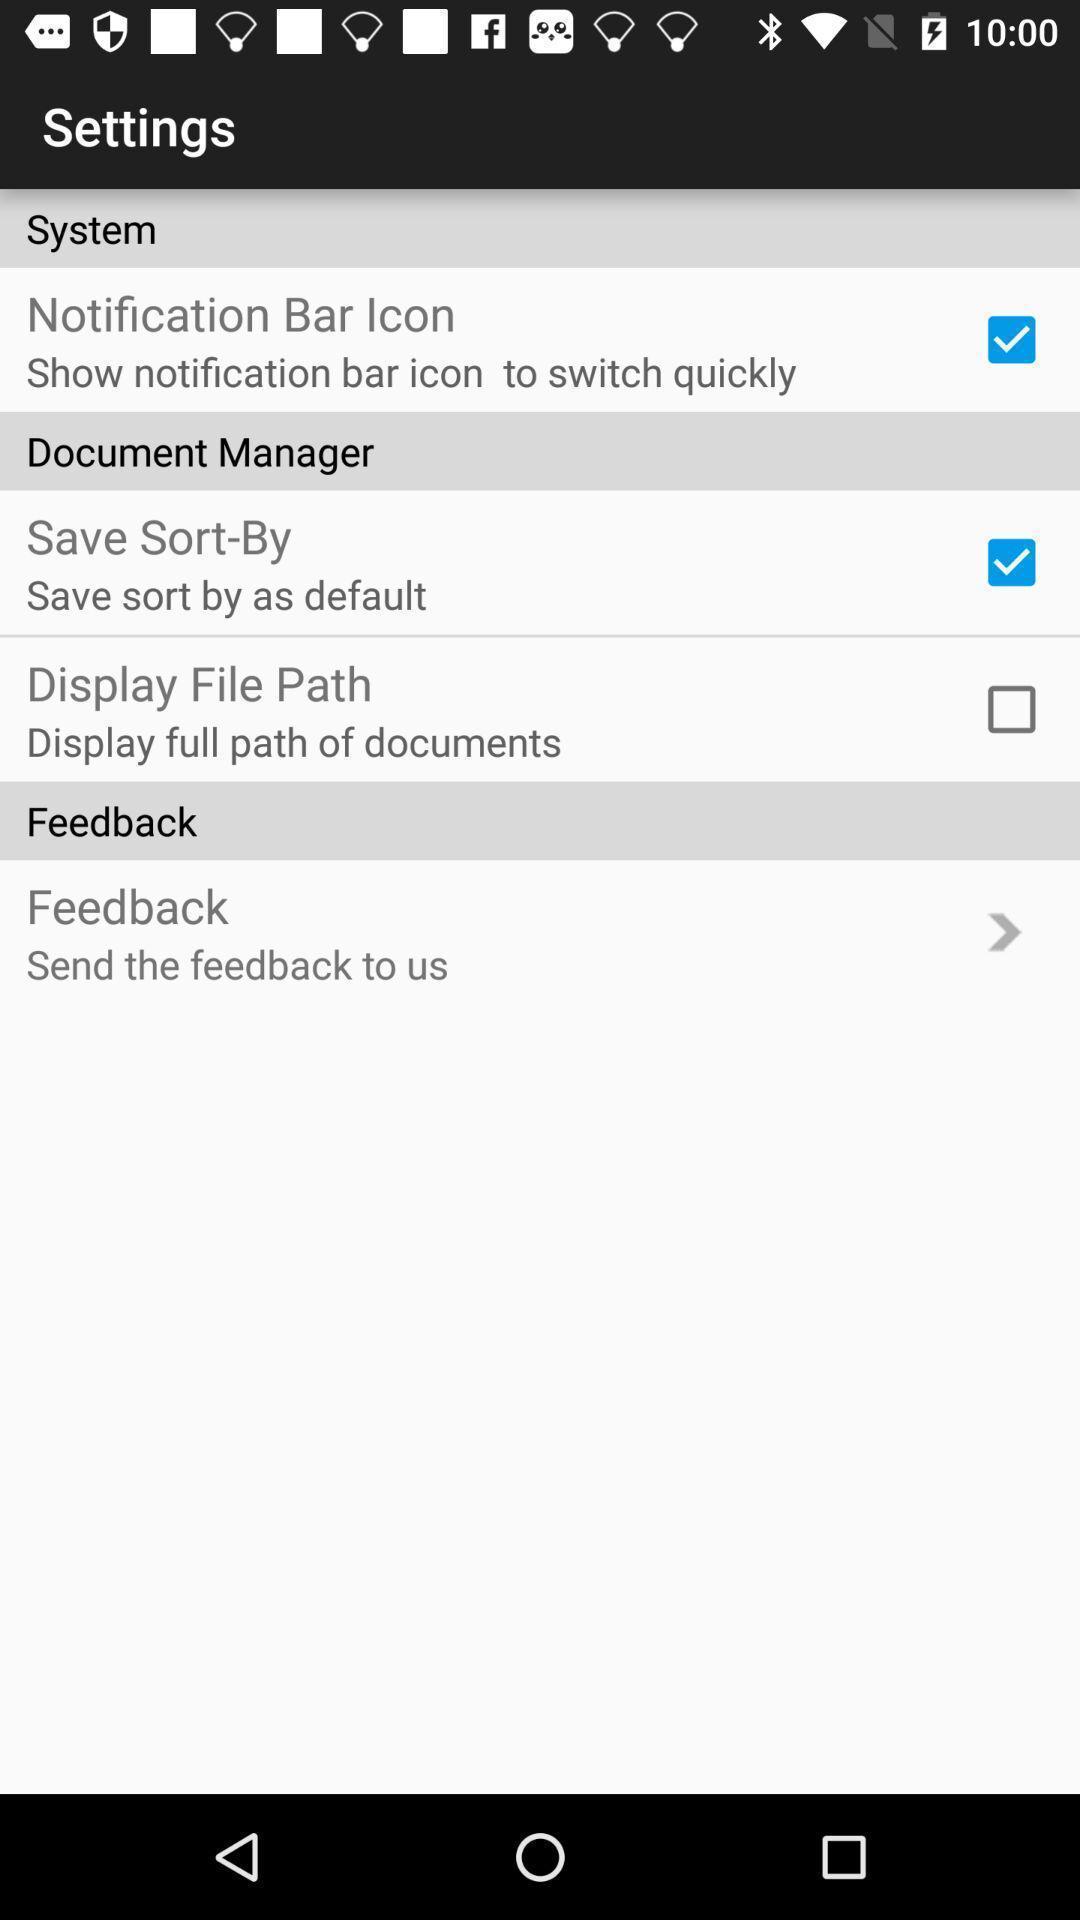What details can you identify in this image? Settings page. 